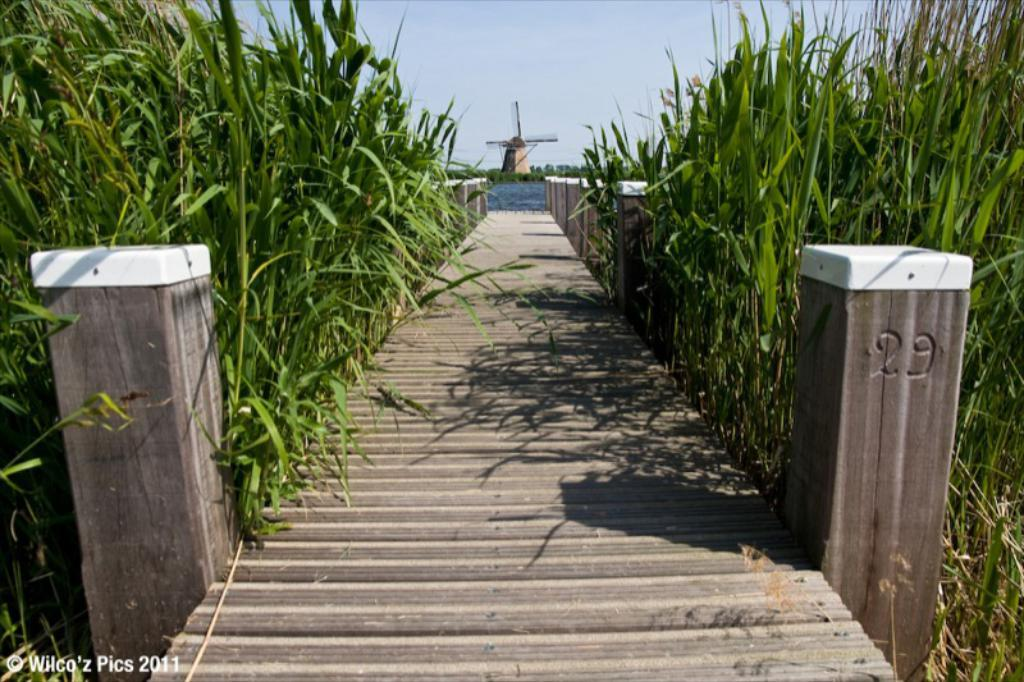What structure can be seen in the image? There is a bridge in the image. What are the pillars used for in the bridge? The pillars support the bridge. What type of vegetation is near the bridge? There are trees beside the bridge. What is in front of the bridge? There is water and a windmill in front of the bridge. What can be seen in the sky in the image? The sky is visible in the image. What type of animals can be seen at the zoo in the image? There is no zoo present in the image; it features a bridge, trees, water, a windmill, and the sky. What type of breakfast is being served in the image? There is no breakfast or any food items present in the image. 